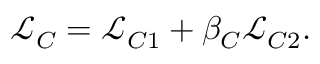Convert formula to latex. <formula><loc_0><loc_0><loc_500><loc_500>\begin{array} { r } { \mathcal { L } _ { C } = \mathcal { L } _ { C 1 } + \beta _ { C } \mathcal { L } _ { C 2 } . } \end{array}</formula> 